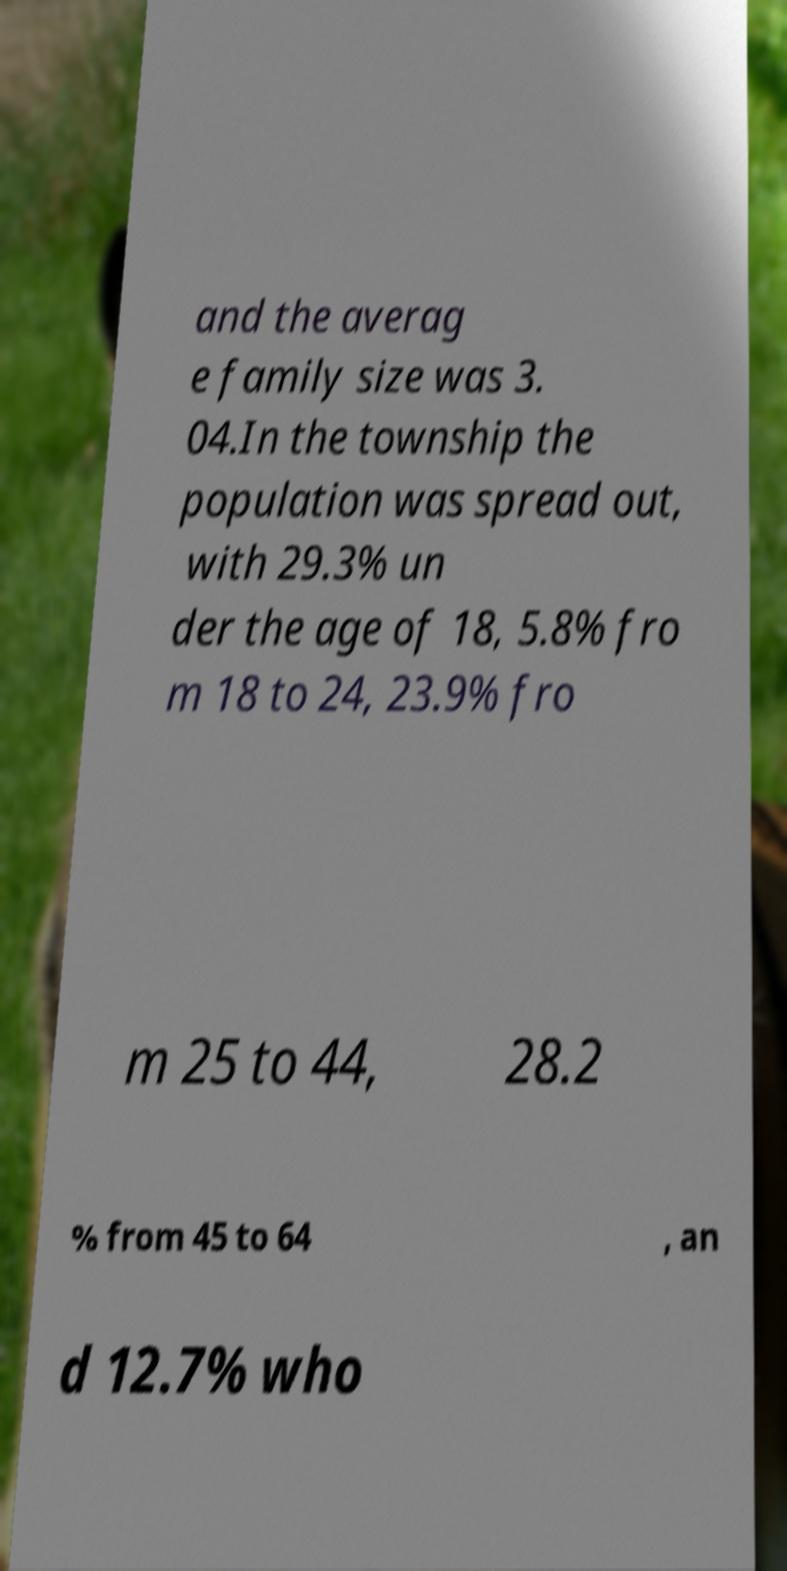I need the written content from this picture converted into text. Can you do that? and the averag e family size was 3. 04.In the township the population was spread out, with 29.3% un der the age of 18, 5.8% fro m 18 to 24, 23.9% fro m 25 to 44, 28.2 % from 45 to 64 , an d 12.7% who 